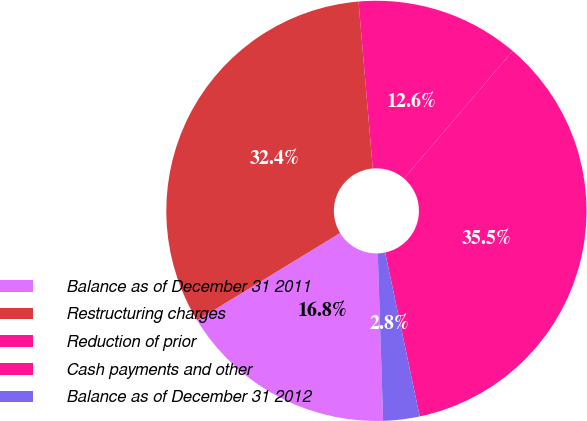<chart> <loc_0><loc_0><loc_500><loc_500><pie_chart><fcel>Balance as of December 31 2011<fcel>Restructuring charges<fcel>Reduction of prior<fcel>Cash payments and other<fcel>Balance as of December 31 2012<nl><fcel>16.78%<fcel>32.37%<fcel>12.59%<fcel>35.46%<fcel>2.8%<nl></chart> 